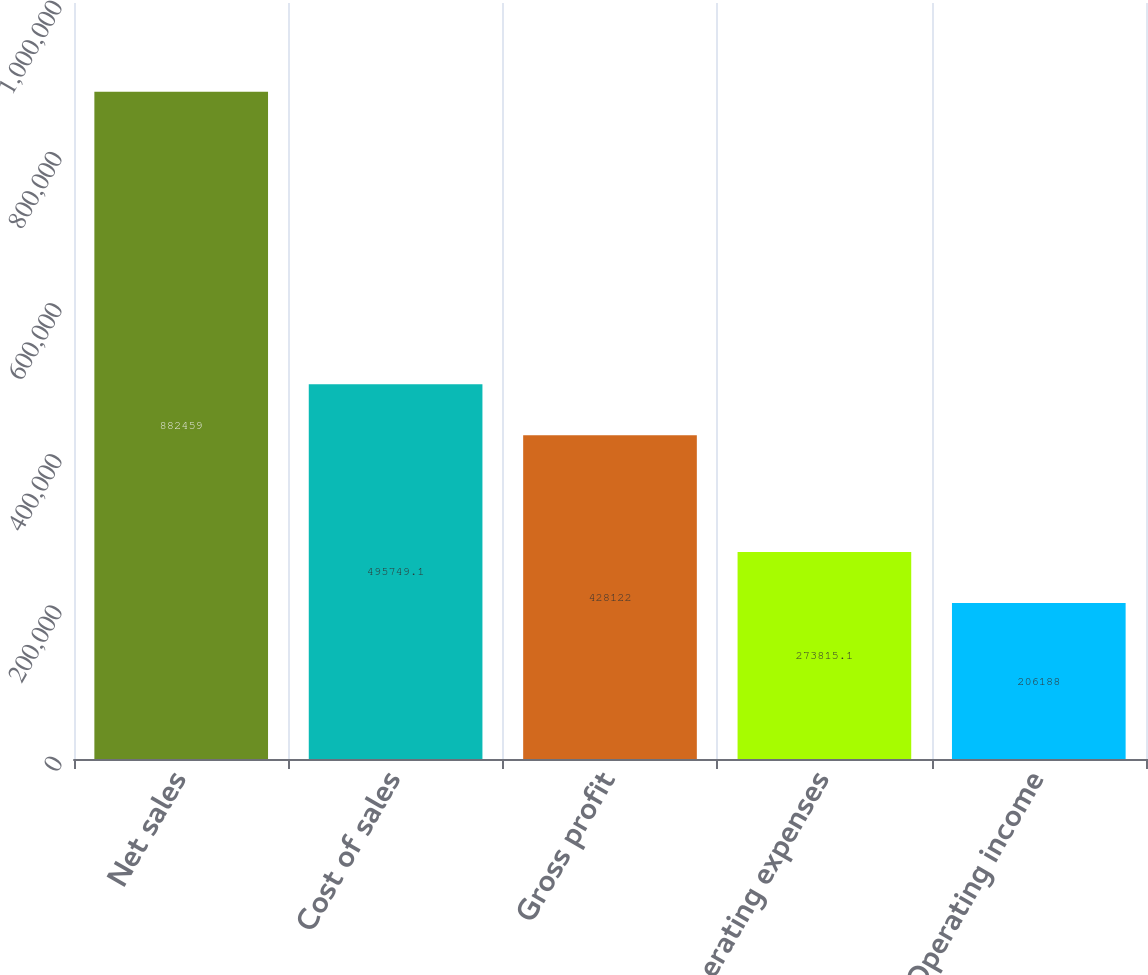<chart> <loc_0><loc_0><loc_500><loc_500><bar_chart><fcel>Net sales<fcel>Cost of sales<fcel>Gross profit<fcel>Operating expenses<fcel>Operating income<nl><fcel>882459<fcel>495749<fcel>428122<fcel>273815<fcel>206188<nl></chart> 